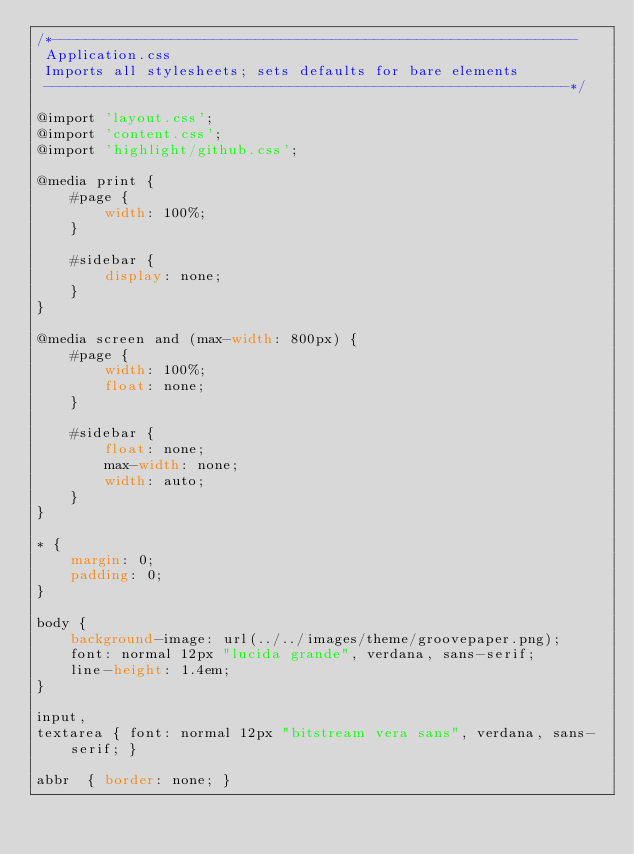<code> <loc_0><loc_0><loc_500><loc_500><_CSS_>/*--------------------------------------------------------------
 Application.css
 Imports all stylesheets; sets defaults for bare elements
 --------------------------------------------------------------*/

@import 'layout.css';
@import 'content.css';
@import 'highlight/github.css';

@media print {
    #page {
        width: 100%;
    }

    #sidebar {
        display: none;
    }
}

@media screen and (max-width: 800px) {
    #page {
        width: 100%;
        float: none;
    }

    #sidebar {
        float: none;
        max-width: none;
        width: auto;
    }
}

* {
    margin: 0;
    padding: 0;
}

body {
    background-image: url(../../images/theme/groovepaper.png);
    font: normal 12px "lucida grande", verdana, sans-serif;
    line-height: 1.4em;
}

input,
textarea { font: normal 12px "bitstream vera sans", verdana, sans-serif; }

abbr  { border: none; }</code> 